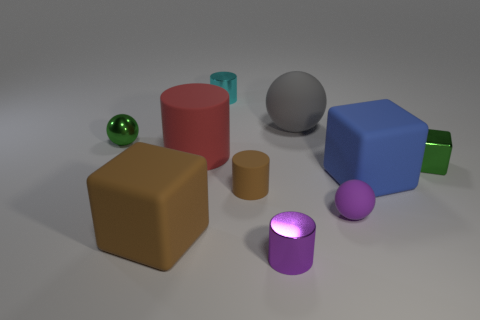Subtract all small brown cylinders. How many cylinders are left? 3 Subtract 2 blocks. How many blocks are left? 1 Subtract all red balls. Subtract all yellow cylinders. How many balls are left? 3 Subtract all red cylinders. How many green spheres are left? 1 Subtract all red balls. Subtract all green metal spheres. How many objects are left? 9 Add 9 big cylinders. How many big cylinders are left? 10 Add 1 small blocks. How many small blocks exist? 2 Subtract all purple cylinders. How many cylinders are left? 3 Subtract 1 blue blocks. How many objects are left? 9 Subtract all cylinders. How many objects are left? 6 